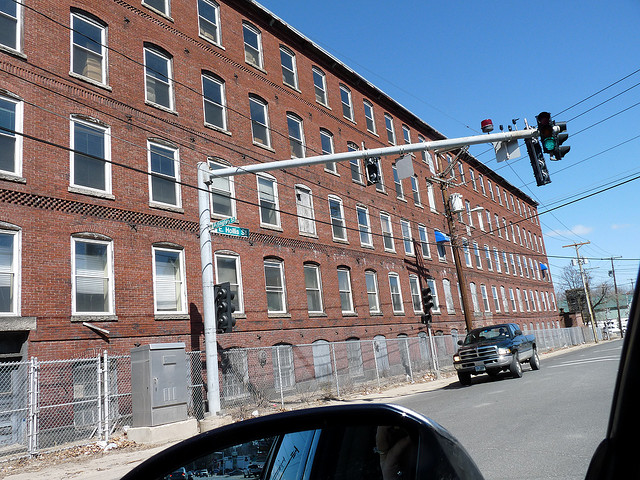Identify and read out the text in this image. St. 